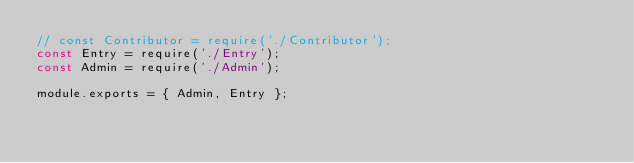<code> <loc_0><loc_0><loc_500><loc_500><_JavaScript_>// const Contributor = require('./Contributor');
const Entry = require('./Entry');
const Admin = require('./Admin');

module.exports = { Admin, Entry };</code> 